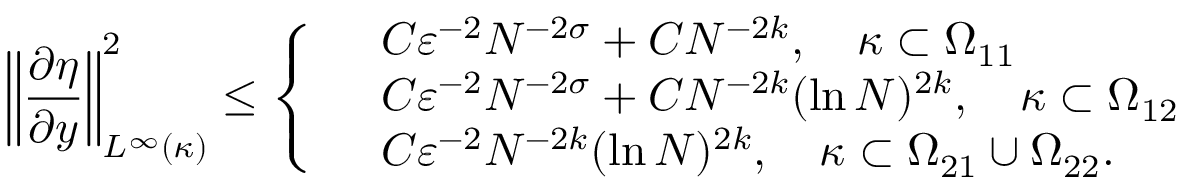Convert formula to latex. <formula><loc_0><loc_0><loc_500><loc_500>\left \| \frac { \partial \eta } { \partial y } \right \| _ { L ^ { \infty } ( \kappa ) } ^ { 2 } \leq \left \{ \begin{array} { r l } & { C \varepsilon ^ { - 2 } N ^ { - 2 \sigma } + C N ^ { - 2 k } , \quad \kappa \subset \Omega _ { 1 1 } } \\ & { C \varepsilon ^ { - 2 } N ^ { - 2 \sigma } + C N ^ { - 2 k } ( \ln N ) ^ { 2 k } , \quad \kappa \subset \Omega _ { 1 2 } } \\ & { C \varepsilon ^ { - 2 } N ^ { - 2 k } ( \ln N ) ^ { 2 k } , \quad \kappa \subset \Omega _ { 2 1 } \cup \Omega _ { 2 2 } . } \end{array}</formula> 